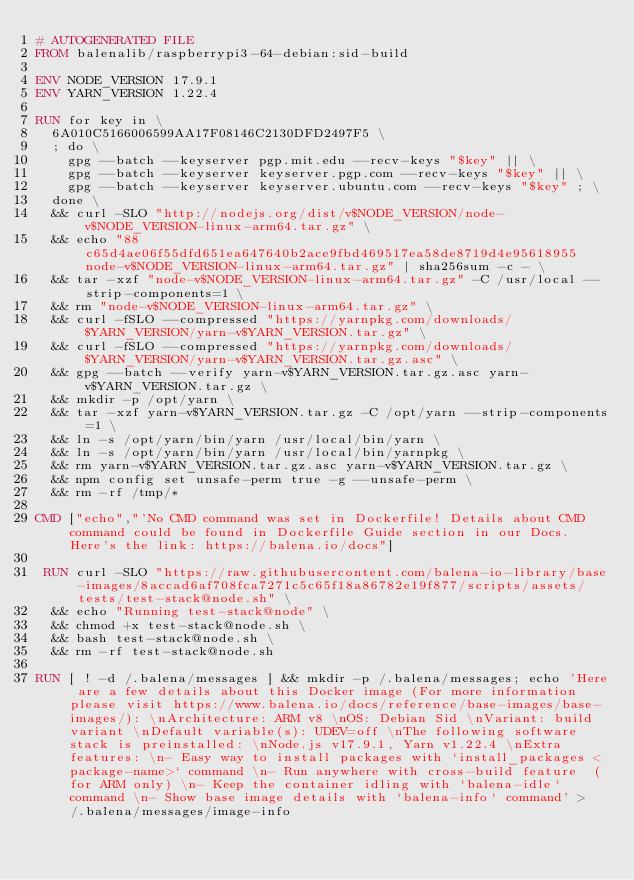<code> <loc_0><loc_0><loc_500><loc_500><_Dockerfile_># AUTOGENERATED FILE
FROM balenalib/raspberrypi3-64-debian:sid-build

ENV NODE_VERSION 17.9.1
ENV YARN_VERSION 1.22.4

RUN for key in \
	6A010C5166006599AA17F08146C2130DFD2497F5 \
	; do \
		gpg --batch --keyserver pgp.mit.edu --recv-keys "$key" || \
		gpg --batch --keyserver keyserver.pgp.com --recv-keys "$key" || \
		gpg --batch --keyserver keyserver.ubuntu.com --recv-keys "$key" ; \
	done \
	&& curl -SLO "http://nodejs.org/dist/v$NODE_VERSION/node-v$NODE_VERSION-linux-arm64.tar.gz" \
	&& echo "88c65d4ae06f55dfd651ea647640b2ace9fbd469517ea58de8719d4e95618955  node-v$NODE_VERSION-linux-arm64.tar.gz" | sha256sum -c - \
	&& tar -xzf "node-v$NODE_VERSION-linux-arm64.tar.gz" -C /usr/local --strip-components=1 \
	&& rm "node-v$NODE_VERSION-linux-arm64.tar.gz" \
	&& curl -fSLO --compressed "https://yarnpkg.com/downloads/$YARN_VERSION/yarn-v$YARN_VERSION.tar.gz" \
	&& curl -fSLO --compressed "https://yarnpkg.com/downloads/$YARN_VERSION/yarn-v$YARN_VERSION.tar.gz.asc" \
	&& gpg --batch --verify yarn-v$YARN_VERSION.tar.gz.asc yarn-v$YARN_VERSION.tar.gz \
	&& mkdir -p /opt/yarn \
	&& tar -xzf yarn-v$YARN_VERSION.tar.gz -C /opt/yarn --strip-components=1 \
	&& ln -s /opt/yarn/bin/yarn /usr/local/bin/yarn \
	&& ln -s /opt/yarn/bin/yarn /usr/local/bin/yarnpkg \
	&& rm yarn-v$YARN_VERSION.tar.gz.asc yarn-v$YARN_VERSION.tar.gz \
	&& npm config set unsafe-perm true -g --unsafe-perm \
	&& rm -rf /tmp/*

CMD ["echo","'No CMD command was set in Dockerfile! Details about CMD command could be found in Dockerfile Guide section in our Docs. Here's the link: https://balena.io/docs"]

 RUN curl -SLO "https://raw.githubusercontent.com/balena-io-library/base-images/8accad6af708fca7271c5c65f18a86782e19f877/scripts/assets/tests/test-stack@node.sh" \
  && echo "Running test-stack@node" \
  && chmod +x test-stack@node.sh \
  && bash test-stack@node.sh \
  && rm -rf test-stack@node.sh 

RUN [ ! -d /.balena/messages ] && mkdir -p /.balena/messages; echo 'Here are a few details about this Docker image (For more information please visit https://www.balena.io/docs/reference/base-images/base-images/): \nArchitecture: ARM v8 \nOS: Debian Sid \nVariant: build variant \nDefault variable(s): UDEV=off \nThe following software stack is preinstalled: \nNode.js v17.9.1, Yarn v1.22.4 \nExtra features: \n- Easy way to install packages with `install_packages <package-name>` command \n- Run anywhere with cross-build feature  (for ARM only) \n- Keep the container idling with `balena-idle` command \n- Show base image details with `balena-info` command' > /.balena/messages/image-info</code> 